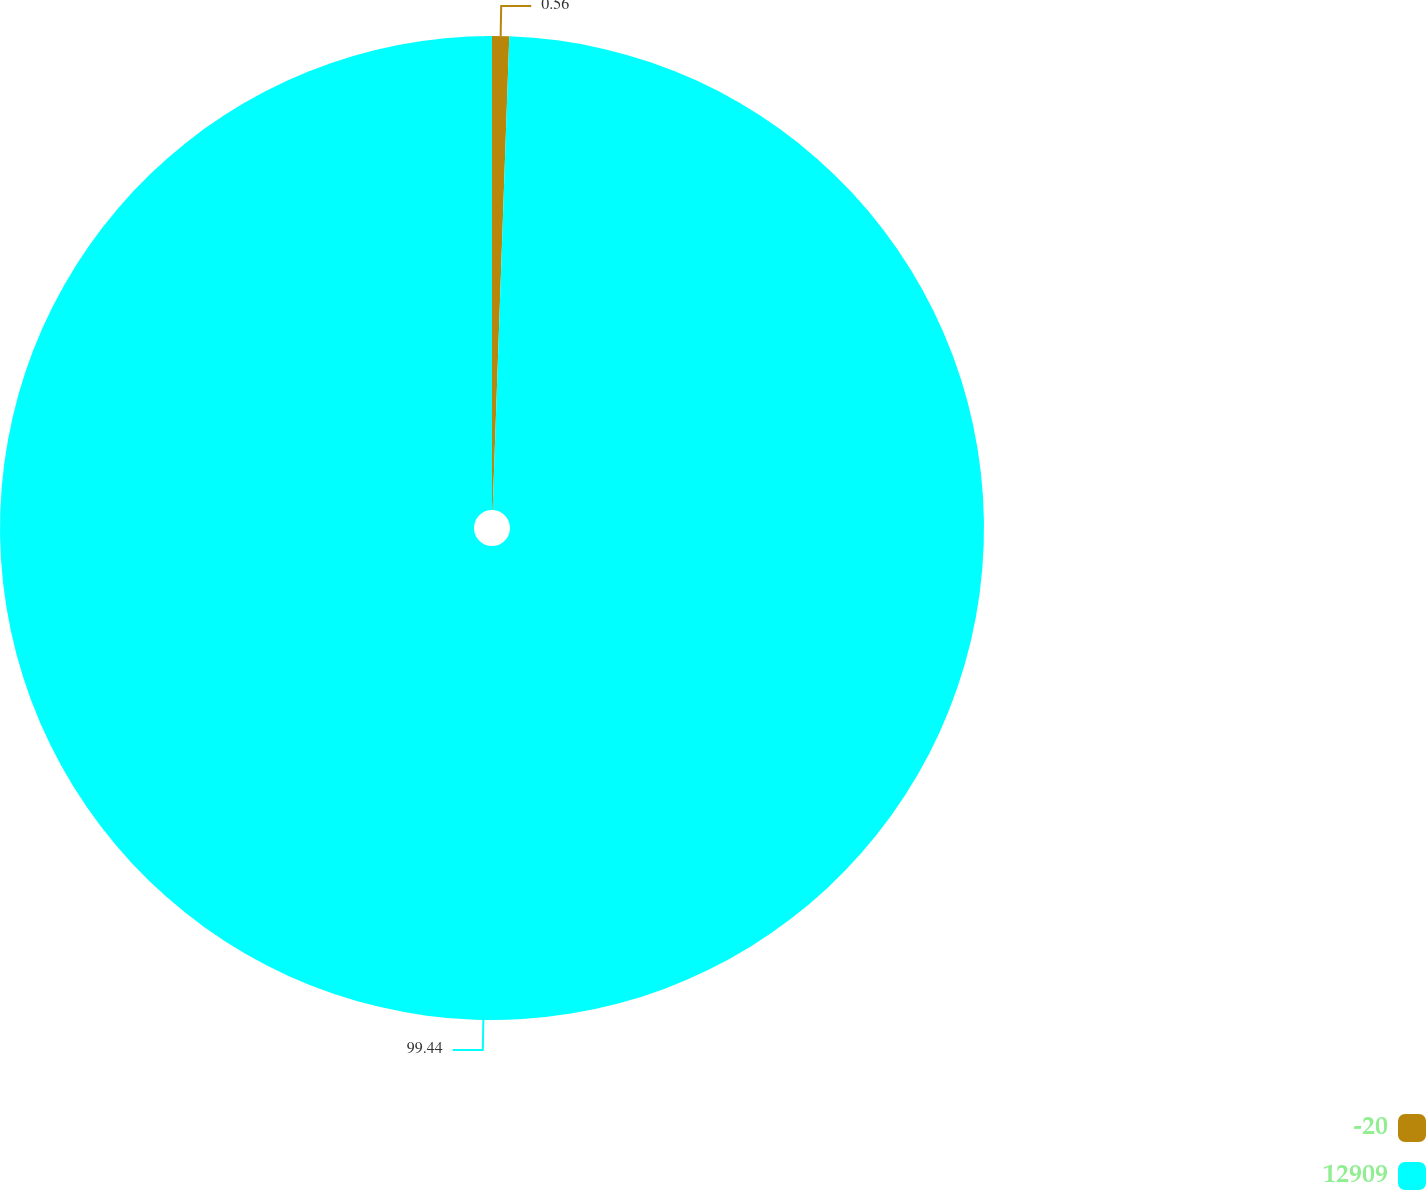Convert chart. <chart><loc_0><loc_0><loc_500><loc_500><pie_chart><fcel>-20<fcel>12909<nl><fcel>0.56%<fcel>99.44%<nl></chart> 